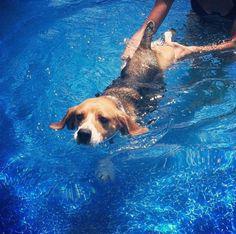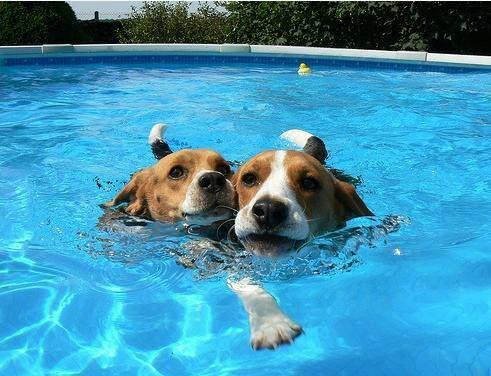The first image is the image on the left, the second image is the image on the right. For the images displayed, is the sentence "There are two beagles swimming and both of them have their heads above water." factually correct? Answer yes or no. No. The first image is the image on the left, the second image is the image on the right. For the images shown, is this caption "Dogs are swimming in an outdoor swimming pool." true? Answer yes or no. Yes. 